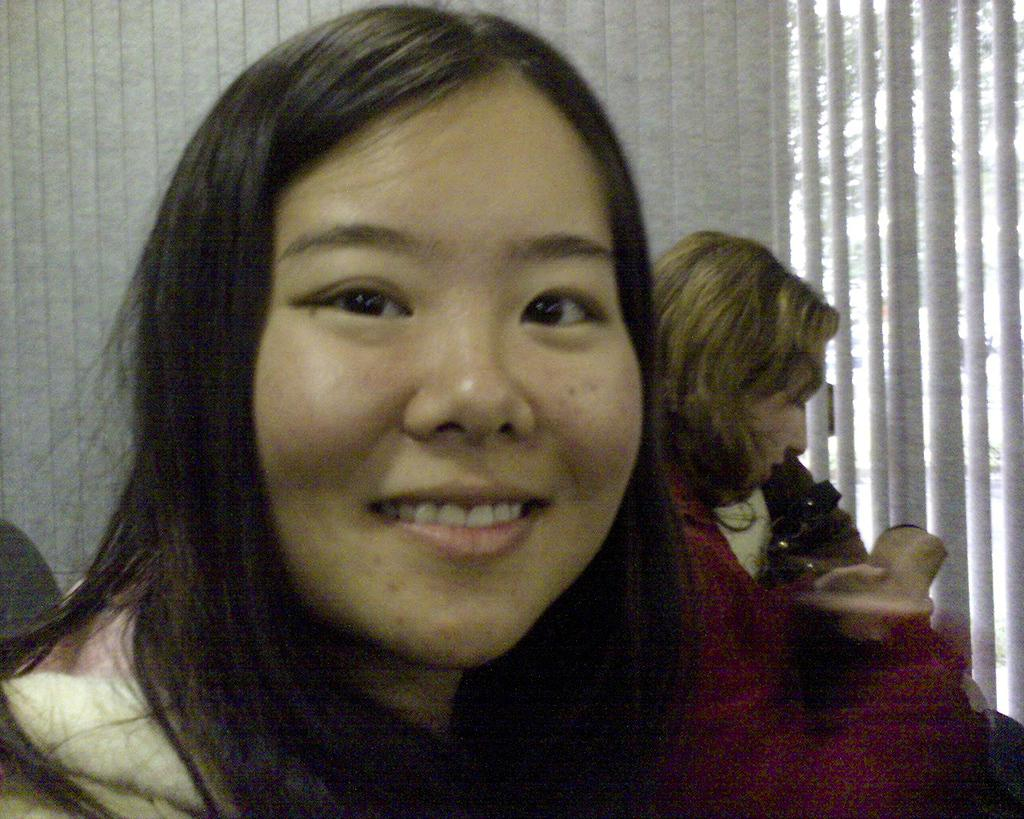How many women are present in the image? There are two women in the image. Can you describe the facial expression of one of the women? One of the women is smiling. What type of boat can be seen in the image? There is no boat present in the image. What is the end result of the women's actions in the image? The image does not depict any actions or events that would have an end result. 